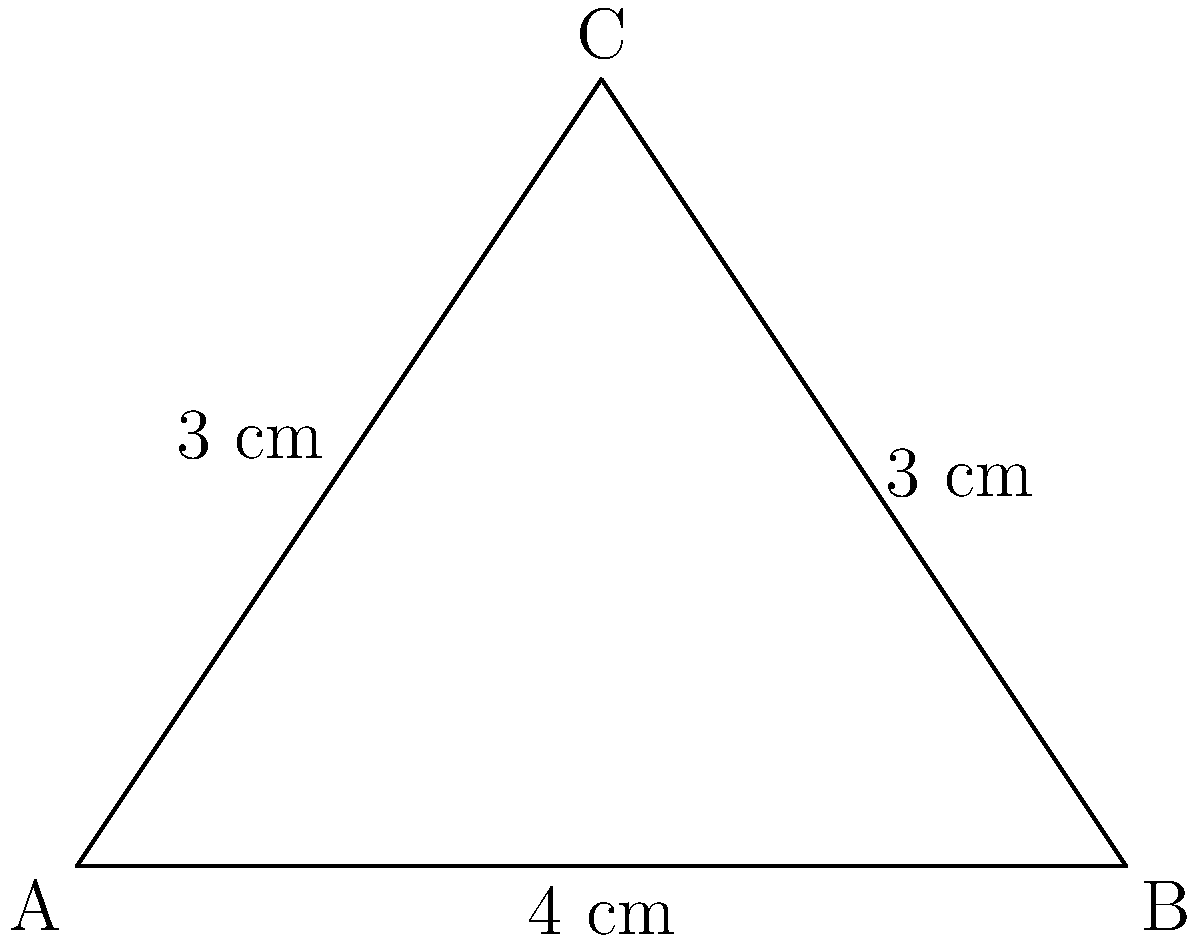In your home cinema room, you've decided to display two iconic movie posters side by side. The first poster, representing "Casablanca," is 4 cm wide and 3 cm tall. The second poster, for "Citizen Kane," is also 3 cm tall but forms a right angle with the "Casablanca" poster. What is the angle between these two classic film posters? Let's approach this step-by-step:

1) The situation forms a right-angled triangle, where:
   - The "Casablanca" poster forms the base (4 cm wide)
   - Both posters are 3 cm tall, forming the other two sides

2) We need to find the angle between these posters, which is the angle opposite the 4 cm side in our triangle.

3) We can use the cosine function to find this angle. In a triangle ABC where C is the right angle:

   $$\cos A = \frac{\text{adjacent}}{\text{hypotenuse}}$$

4) In our case:
   - The adjacent side is 3 cm (height of the poster)
   - The hypotenuse is the "Citizen Kane" poster, which we can calculate using the Pythagorean theorem:
     $$\text{hypotenuse}^2 = 3^2 + 4^2 = 9 + 16 = 25$$
     $$\text{hypotenuse} = \sqrt{25} = 5 \text{ cm}$$

5) Now we can calculate the cosine of our angle:

   $$\cos A = \frac{3}{5}$$

6) To find the angle, we take the inverse cosine (arccos):

   $$A = \arccos(\frac{3}{5})$$

7) Calculate this value:

   $$A \approx 53.13^\circ$$

Therefore, the angle between the two movie posters is approximately 53.13°.
Answer: 53.13° 